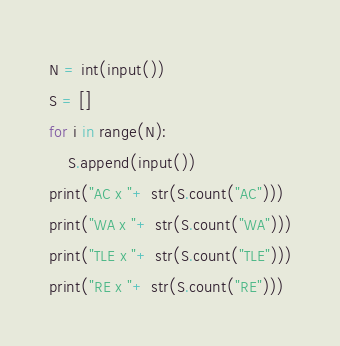Convert code to text. <code><loc_0><loc_0><loc_500><loc_500><_Python_>N = int(input())
S = []
for i in range(N):
    S.append(input())
print("AC x "+ str(S.count("AC")))
print("WA x "+ str(S.count("WA")))
print("TLE x "+ str(S.count("TLE")))
print("RE x "+ str(S.count("RE")))</code> 